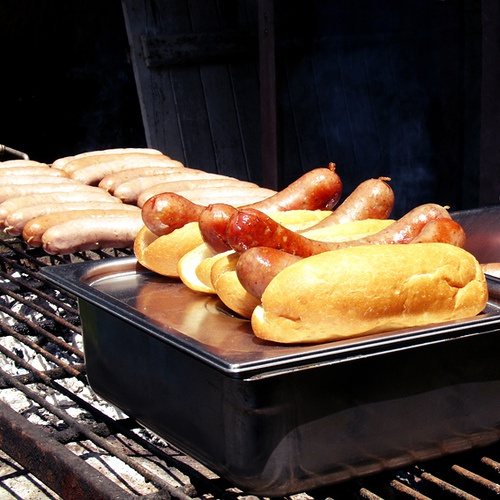Describe the objects in this image and their specific colors. I can see hot dog in black, tan, and beige tones, hot dog in black, gold, khaki, and orange tones, hot dog in black, brown, tan, and red tones, hot dog in black, tan, red, and brown tones, and hot dog in black, ivory, orange, brown, and khaki tones in this image. 